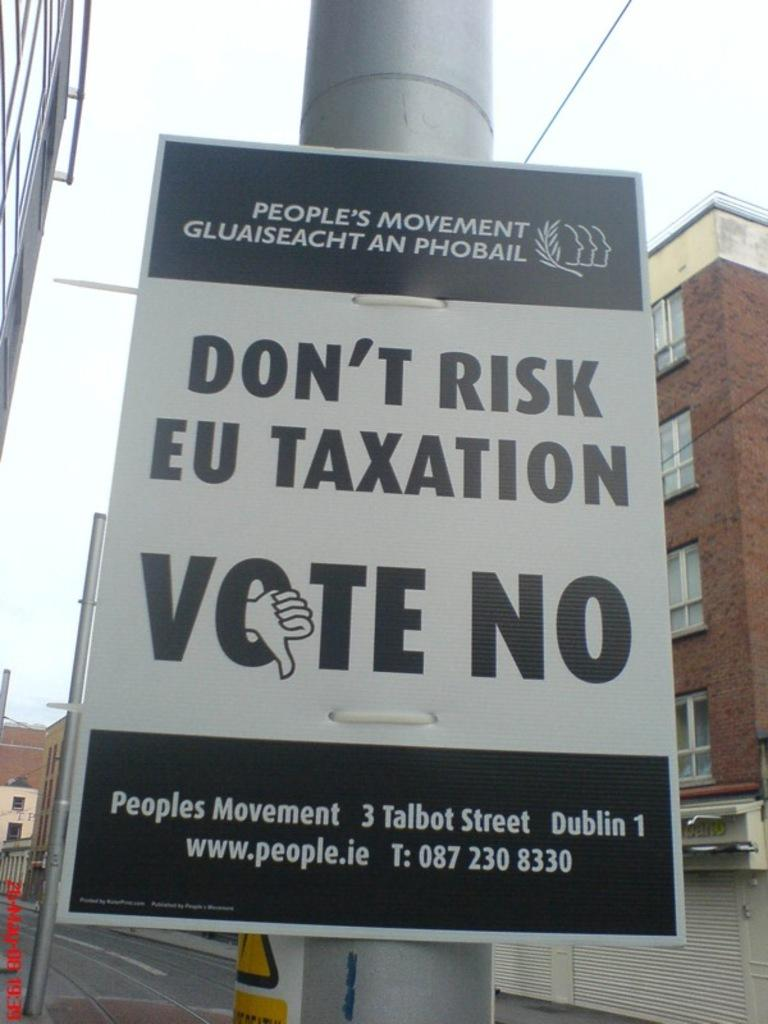<image>
Share a concise interpretation of the image provided. A political sign put out by the People's Movement promoting no taxation. 